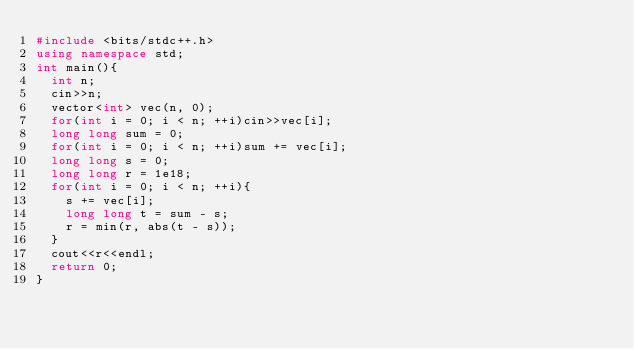<code> <loc_0><loc_0><loc_500><loc_500><_C++_>#include <bits/stdc++.h>
using namespace std;
int main(){
  int n;
  cin>>n;
  vector<int> vec(n, 0);
  for(int i = 0; i < n; ++i)cin>>vec[i];
  long long sum = 0;
  for(int i = 0; i < n; ++i)sum += vec[i];
  long long s = 0;
  long long r = 1e18;
  for(int i = 0; i < n; ++i){
    s += vec[i];
    long long t = sum - s;
    r = min(r, abs(t - s));
  }
  cout<<r<<endl;
  return 0;
}
</code> 